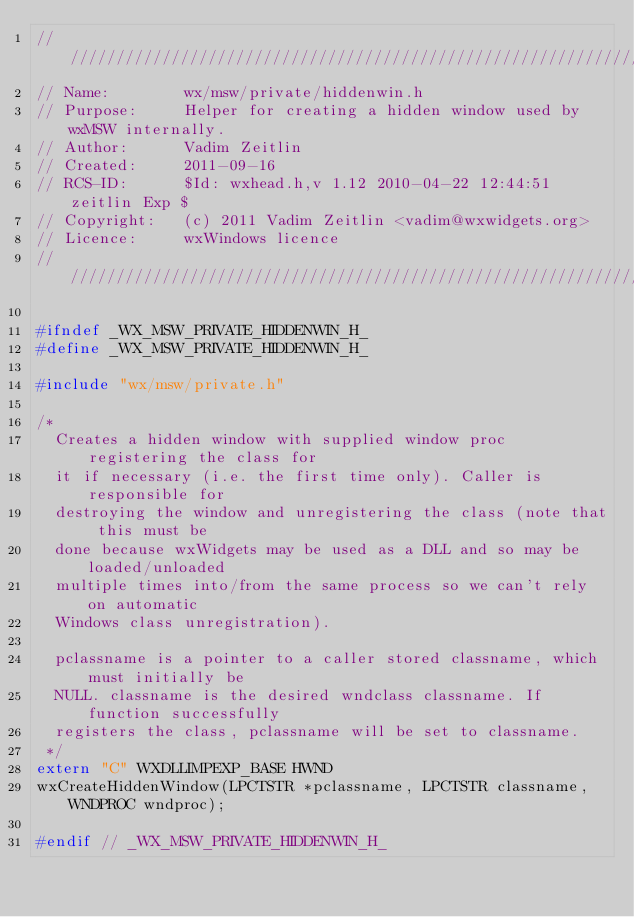<code> <loc_0><loc_0><loc_500><loc_500><_C_>///////////////////////////////////////////////////////////////////////////////
// Name:        wx/msw/private/hiddenwin.h
// Purpose:     Helper for creating a hidden window used by wxMSW internally.
// Author:      Vadim Zeitlin
// Created:     2011-09-16
// RCS-ID:      $Id: wxhead.h,v 1.12 2010-04-22 12:44:51 zeitlin Exp $
// Copyright:   (c) 2011 Vadim Zeitlin <vadim@wxwidgets.org>
// Licence:     wxWindows licence
///////////////////////////////////////////////////////////////////////////////

#ifndef _WX_MSW_PRIVATE_HIDDENWIN_H_
#define _WX_MSW_PRIVATE_HIDDENWIN_H_

#include "wx/msw/private.h"

/*
  Creates a hidden window with supplied window proc registering the class for
  it if necessary (i.e. the first time only). Caller is responsible for
  destroying the window and unregistering the class (note that this must be
  done because wxWidgets may be used as a DLL and so may be loaded/unloaded
  multiple times into/from the same process so we can't rely on automatic
  Windows class unregistration).

  pclassname is a pointer to a caller stored classname, which must initially be
  NULL. classname is the desired wndclass classname. If function successfully
  registers the class, pclassname will be set to classname.
 */
extern "C" WXDLLIMPEXP_BASE HWND
wxCreateHiddenWindow(LPCTSTR *pclassname, LPCTSTR classname, WNDPROC wndproc);

#endif // _WX_MSW_PRIVATE_HIDDENWIN_H_
</code> 